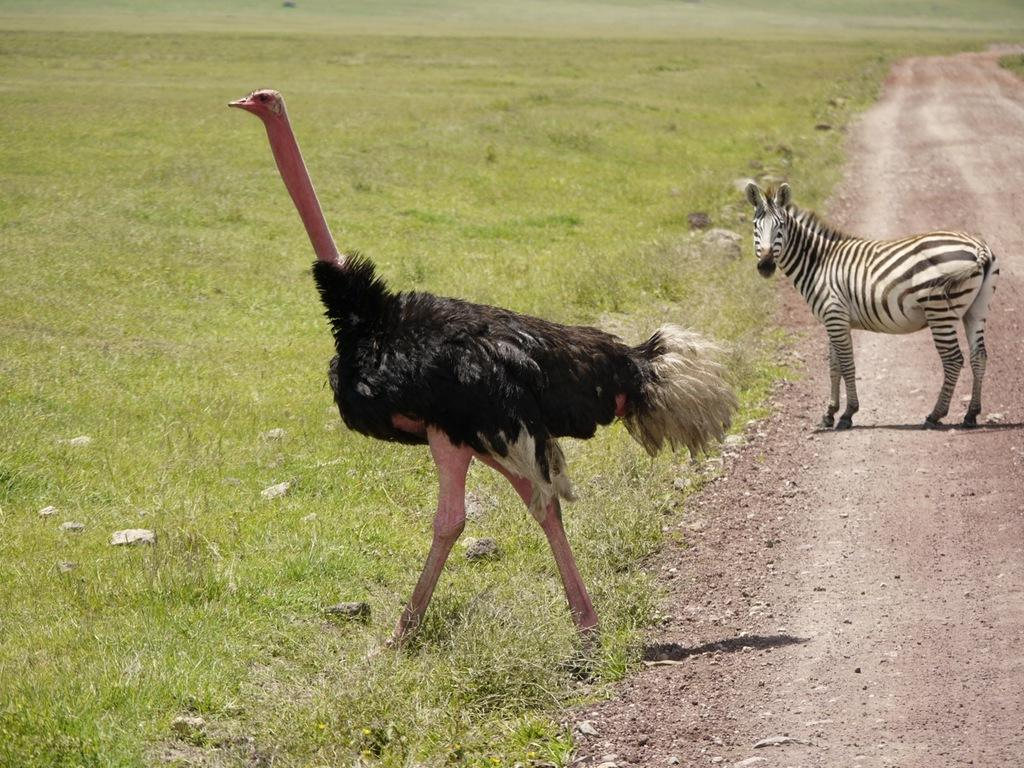What animals can be seen in the image? There is an ostrich and a quagga in the in the image. What type of vegetation is visible in the background of the image? There is grass in the background of the image. What type of terrain is visible in the background of the image? There are stones and the ground visible in the background of the image. What type of crown is the ostrich wearing in the image? There is no crown present in the image; the ostrich is not wearing any headgear. 